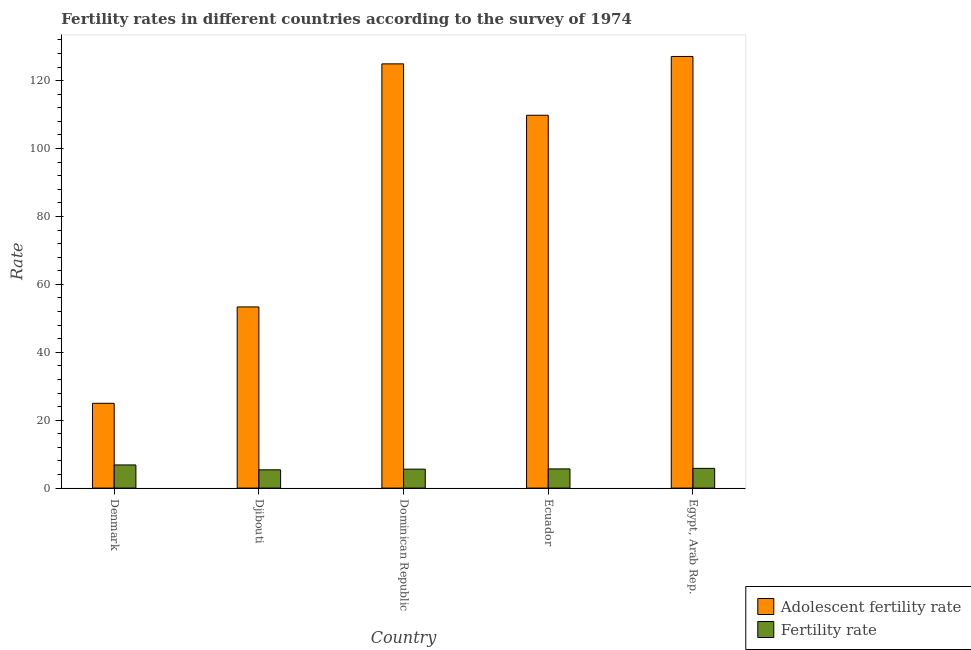How many different coloured bars are there?
Your answer should be compact. 2. Are the number of bars on each tick of the X-axis equal?
Offer a terse response. Yes. How many bars are there on the 1st tick from the left?
Ensure brevity in your answer.  2. What is the label of the 3rd group of bars from the left?
Offer a very short reply. Dominican Republic. What is the fertility rate in Dominican Republic?
Provide a short and direct response. 5.58. Across all countries, what is the maximum fertility rate?
Your answer should be very brief. 6.82. Across all countries, what is the minimum adolescent fertility rate?
Provide a short and direct response. 24.97. In which country was the adolescent fertility rate maximum?
Your response must be concise. Egypt, Arab Rep. In which country was the adolescent fertility rate minimum?
Keep it short and to the point. Denmark. What is the total adolescent fertility rate in the graph?
Give a very brief answer. 440.2. What is the difference between the adolescent fertility rate in Djibouti and that in Egypt, Arab Rep.?
Give a very brief answer. -73.77. What is the difference between the fertility rate in Denmark and the adolescent fertility rate in Ecuador?
Make the answer very short. -102.99. What is the average fertility rate per country?
Your response must be concise. 5.85. What is the difference between the adolescent fertility rate and fertility rate in Dominican Republic?
Your answer should be compact. 119.36. What is the ratio of the fertility rate in Denmark to that in Ecuador?
Offer a terse response. 1.21. Is the fertility rate in Denmark less than that in Ecuador?
Provide a succinct answer. No. What is the difference between the highest and the second highest fertility rate?
Give a very brief answer. 1.01. What is the difference between the highest and the lowest adolescent fertility rate?
Your answer should be compact. 102.15. In how many countries, is the adolescent fertility rate greater than the average adolescent fertility rate taken over all countries?
Ensure brevity in your answer.  3. Is the sum of the fertility rate in Denmark and Dominican Republic greater than the maximum adolescent fertility rate across all countries?
Make the answer very short. No. What does the 1st bar from the left in Dominican Republic represents?
Provide a short and direct response. Adolescent fertility rate. What does the 2nd bar from the right in Egypt, Arab Rep. represents?
Give a very brief answer. Adolescent fertility rate. Are all the bars in the graph horizontal?
Provide a short and direct response. No. What is the difference between two consecutive major ticks on the Y-axis?
Provide a short and direct response. 20. Are the values on the major ticks of Y-axis written in scientific E-notation?
Your response must be concise. No. Does the graph contain any zero values?
Provide a short and direct response. No. Does the graph contain grids?
Give a very brief answer. No. What is the title of the graph?
Give a very brief answer. Fertility rates in different countries according to the survey of 1974. Does "Foreign liabilities" appear as one of the legend labels in the graph?
Your answer should be very brief. No. What is the label or title of the Y-axis?
Your answer should be very brief. Rate. What is the Rate of Adolescent fertility rate in Denmark?
Provide a succinct answer. 24.97. What is the Rate in Fertility rate in Denmark?
Offer a terse response. 6.82. What is the Rate in Adolescent fertility rate in Djibouti?
Offer a terse response. 53.35. What is the Rate in Fertility rate in Djibouti?
Offer a terse response. 5.38. What is the Rate in Adolescent fertility rate in Dominican Republic?
Give a very brief answer. 124.94. What is the Rate of Fertility rate in Dominican Republic?
Your answer should be very brief. 5.58. What is the Rate of Adolescent fertility rate in Ecuador?
Offer a very short reply. 109.8. What is the Rate of Fertility rate in Ecuador?
Offer a terse response. 5.65. What is the Rate of Adolescent fertility rate in Egypt, Arab Rep.?
Provide a succinct answer. 127.12. What is the Rate of Fertility rate in Egypt, Arab Rep.?
Make the answer very short. 5.81. Across all countries, what is the maximum Rate of Adolescent fertility rate?
Provide a succinct answer. 127.12. Across all countries, what is the maximum Rate in Fertility rate?
Provide a short and direct response. 6.82. Across all countries, what is the minimum Rate in Adolescent fertility rate?
Your answer should be compact. 24.97. Across all countries, what is the minimum Rate of Fertility rate?
Provide a succinct answer. 5.38. What is the total Rate in Adolescent fertility rate in the graph?
Give a very brief answer. 440.2. What is the total Rate in Fertility rate in the graph?
Your answer should be compact. 29.23. What is the difference between the Rate of Adolescent fertility rate in Denmark and that in Djibouti?
Ensure brevity in your answer.  -28.38. What is the difference between the Rate of Fertility rate in Denmark and that in Djibouti?
Ensure brevity in your answer.  1.44. What is the difference between the Rate in Adolescent fertility rate in Denmark and that in Dominican Republic?
Offer a very short reply. -99.97. What is the difference between the Rate of Fertility rate in Denmark and that in Dominican Republic?
Give a very brief answer. 1.24. What is the difference between the Rate of Adolescent fertility rate in Denmark and that in Ecuador?
Keep it short and to the point. -84.83. What is the difference between the Rate in Fertility rate in Denmark and that in Ecuador?
Make the answer very short. 1.17. What is the difference between the Rate in Adolescent fertility rate in Denmark and that in Egypt, Arab Rep.?
Give a very brief answer. -102.15. What is the difference between the Rate in Fertility rate in Denmark and that in Egypt, Arab Rep.?
Offer a terse response. 1.01. What is the difference between the Rate in Adolescent fertility rate in Djibouti and that in Dominican Republic?
Give a very brief answer. -71.59. What is the difference between the Rate in Fertility rate in Djibouti and that in Dominican Republic?
Keep it short and to the point. -0.2. What is the difference between the Rate of Adolescent fertility rate in Djibouti and that in Ecuador?
Provide a succinct answer. -56.45. What is the difference between the Rate in Fertility rate in Djibouti and that in Ecuador?
Your answer should be very brief. -0.27. What is the difference between the Rate in Adolescent fertility rate in Djibouti and that in Egypt, Arab Rep.?
Offer a terse response. -73.77. What is the difference between the Rate in Fertility rate in Djibouti and that in Egypt, Arab Rep.?
Provide a succinct answer. -0.43. What is the difference between the Rate of Adolescent fertility rate in Dominican Republic and that in Ecuador?
Offer a terse response. 15.14. What is the difference between the Rate in Fertility rate in Dominican Republic and that in Ecuador?
Offer a very short reply. -0.07. What is the difference between the Rate in Adolescent fertility rate in Dominican Republic and that in Egypt, Arab Rep.?
Offer a terse response. -2.18. What is the difference between the Rate of Fertility rate in Dominican Republic and that in Egypt, Arab Rep.?
Your answer should be compact. -0.23. What is the difference between the Rate of Adolescent fertility rate in Ecuador and that in Egypt, Arab Rep.?
Provide a succinct answer. -17.32. What is the difference between the Rate of Fertility rate in Ecuador and that in Egypt, Arab Rep.?
Offer a very short reply. -0.16. What is the difference between the Rate in Adolescent fertility rate in Denmark and the Rate in Fertility rate in Djibouti?
Your response must be concise. 19.59. What is the difference between the Rate of Adolescent fertility rate in Denmark and the Rate of Fertility rate in Dominican Republic?
Keep it short and to the point. 19.4. What is the difference between the Rate of Adolescent fertility rate in Denmark and the Rate of Fertility rate in Ecuador?
Provide a succinct answer. 19.32. What is the difference between the Rate in Adolescent fertility rate in Denmark and the Rate in Fertility rate in Egypt, Arab Rep.?
Your response must be concise. 19.17. What is the difference between the Rate in Adolescent fertility rate in Djibouti and the Rate in Fertility rate in Dominican Republic?
Offer a very short reply. 47.78. What is the difference between the Rate in Adolescent fertility rate in Djibouti and the Rate in Fertility rate in Ecuador?
Offer a very short reply. 47.7. What is the difference between the Rate in Adolescent fertility rate in Djibouti and the Rate in Fertility rate in Egypt, Arab Rep.?
Give a very brief answer. 47.55. What is the difference between the Rate in Adolescent fertility rate in Dominican Republic and the Rate in Fertility rate in Ecuador?
Your response must be concise. 119.29. What is the difference between the Rate of Adolescent fertility rate in Dominican Republic and the Rate of Fertility rate in Egypt, Arab Rep.?
Keep it short and to the point. 119.13. What is the difference between the Rate of Adolescent fertility rate in Ecuador and the Rate of Fertility rate in Egypt, Arab Rep.?
Make the answer very short. 104. What is the average Rate of Adolescent fertility rate per country?
Offer a very short reply. 88.04. What is the average Rate in Fertility rate per country?
Give a very brief answer. 5.85. What is the difference between the Rate in Adolescent fertility rate and Rate in Fertility rate in Denmark?
Offer a terse response. 18.16. What is the difference between the Rate of Adolescent fertility rate and Rate of Fertility rate in Djibouti?
Your response must be concise. 47.97. What is the difference between the Rate in Adolescent fertility rate and Rate in Fertility rate in Dominican Republic?
Keep it short and to the point. 119.36. What is the difference between the Rate of Adolescent fertility rate and Rate of Fertility rate in Ecuador?
Ensure brevity in your answer.  104.15. What is the difference between the Rate in Adolescent fertility rate and Rate in Fertility rate in Egypt, Arab Rep.?
Provide a short and direct response. 121.32. What is the ratio of the Rate of Adolescent fertility rate in Denmark to that in Djibouti?
Ensure brevity in your answer.  0.47. What is the ratio of the Rate of Fertility rate in Denmark to that in Djibouti?
Offer a very short reply. 1.27. What is the ratio of the Rate in Adolescent fertility rate in Denmark to that in Dominican Republic?
Offer a very short reply. 0.2. What is the ratio of the Rate of Fertility rate in Denmark to that in Dominican Republic?
Your response must be concise. 1.22. What is the ratio of the Rate in Adolescent fertility rate in Denmark to that in Ecuador?
Your answer should be very brief. 0.23. What is the ratio of the Rate in Fertility rate in Denmark to that in Ecuador?
Your response must be concise. 1.21. What is the ratio of the Rate of Adolescent fertility rate in Denmark to that in Egypt, Arab Rep.?
Your answer should be very brief. 0.2. What is the ratio of the Rate of Fertility rate in Denmark to that in Egypt, Arab Rep.?
Provide a short and direct response. 1.17. What is the ratio of the Rate in Adolescent fertility rate in Djibouti to that in Dominican Republic?
Your answer should be compact. 0.43. What is the ratio of the Rate of Fertility rate in Djibouti to that in Dominican Republic?
Ensure brevity in your answer.  0.96. What is the ratio of the Rate of Adolescent fertility rate in Djibouti to that in Ecuador?
Your answer should be compact. 0.49. What is the ratio of the Rate in Adolescent fertility rate in Djibouti to that in Egypt, Arab Rep.?
Offer a very short reply. 0.42. What is the ratio of the Rate of Fertility rate in Djibouti to that in Egypt, Arab Rep.?
Provide a succinct answer. 0.93. What is the ratio of the Rate in Adolescent fertility rate in Dominican Republic to that in Ecuador?
Keep it short and to the point. 1.14. What is the ratio of the Rate in Fertility rate in Dominican Republic to that in Ecuador?
Keep it short and to the point. 0.99. What is the ratio of the Rate of Adolescent fertility rate in Dominican Republic to that in Egypt, Arab Rep.?
Your response must be concise. 0.98. What is the ratio of the Rate in Fertility rate in Dominican Republic to that in Egypt, Arab Rep.?
Keep it short and to the point. 0.96. What is the ratio of the Rate in Adolescent fertility rate in Ecuador to that in Egypt, Arab Rep.?
Make the answer very short. 0.86. What is the ratio of the Rate in Fertility rate in Ecuador to that in Egypt, Arab Rep.?
Offer a terse response. 0.97. What is the difference between the highest and the second highest Rate of Adolescent fertility rate?
Make the answer very short. 2.18. What is the difference between the highest and the lowest Rate in Adolescent fertility rate?
Keep it short and to the point. 102.15. What is the difference between the highest and the lowest Rate in Fertility rate?
Provide a succinct answer. 1.44. 